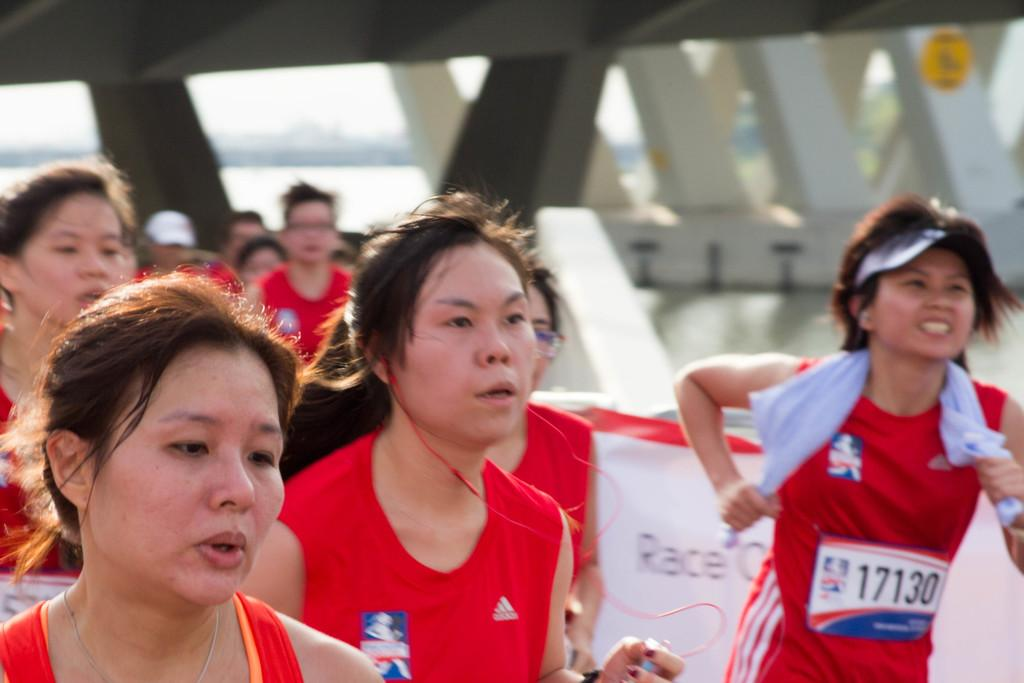Who is present in the image? There are women in the image. What are the women doing? The women are running. What are the women wearing? The women are wearing sports wear. What can be seen in the background of the image? There is a pillars construction visible in the background. How is the pillars construction arranged? The pillars construction is in a zigzag pattern. Reasoning: Let's think step by step by step in order to produce the conversation. We start by identifying the main subjects in the image, which are the women. Then, we describe their actions and attire to provide context. Next, we focus on the background of the image, specifically mentioning the pillars construction and its unique arrangement. Each question is designed to elicit a specific detail about the image that is known from the provided facts. Absurd Question/Answer: What type of haircut do the women have in the image? There is no information about the women's haircuts in the image. What is the texture of the bulb visible in the image? There is no bulb present in the image. What type of haircut do the women have in the image? There is no information about the women's haircuts in the image. What is the texture of the bulb visible in the image? There is no bulb present in the image. 